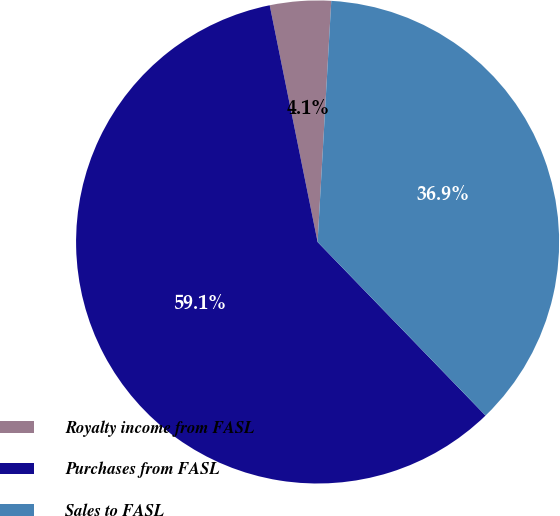Convert chart to OTSL. <chart><loc_0><loc_0><loc_500><loc_500><pie_chart><fcel>Royalty income from FASL<fcel>Purchases from FASL<fcel>Sales to FASL<nl><fcel>4.08%<fcel>59.06%<fcel>36.86%<nl></chart> 